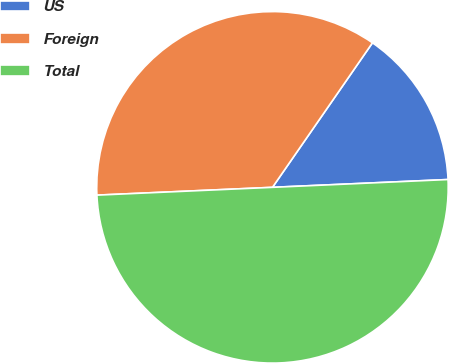Convert chart. <chart><loc_0><loc_0><loc_500><loc_500><pie_chart><fcel>US<fcel>Foreign<fcel>Total<nl><fcel>14.66%<fcel>35.34%<fcel>50.0%<nl></chart> 